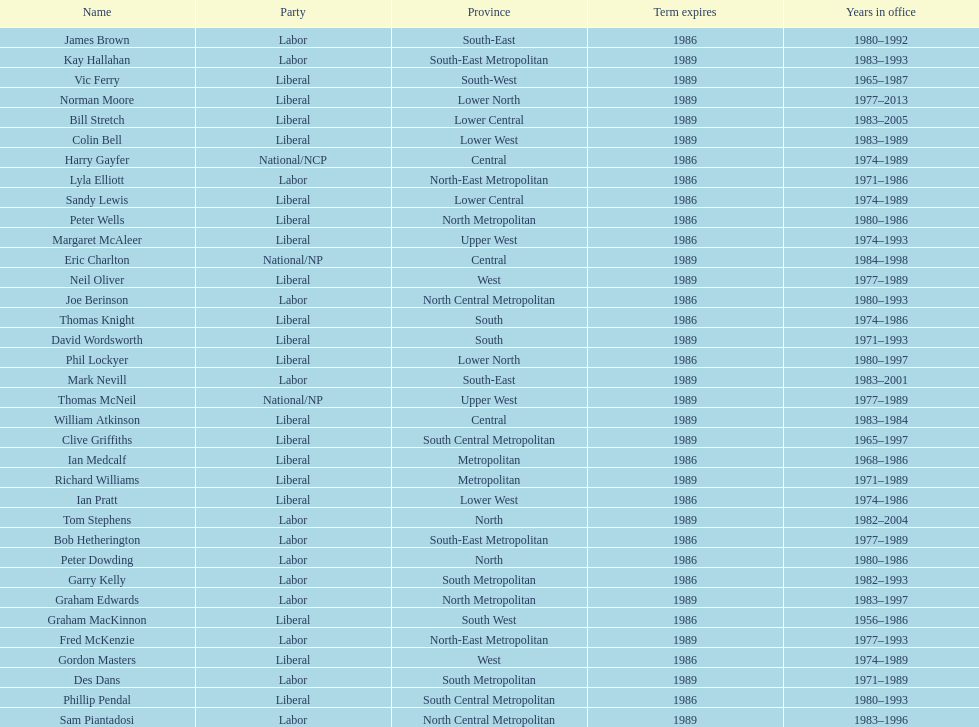How many members were party of lower west province? 2. 